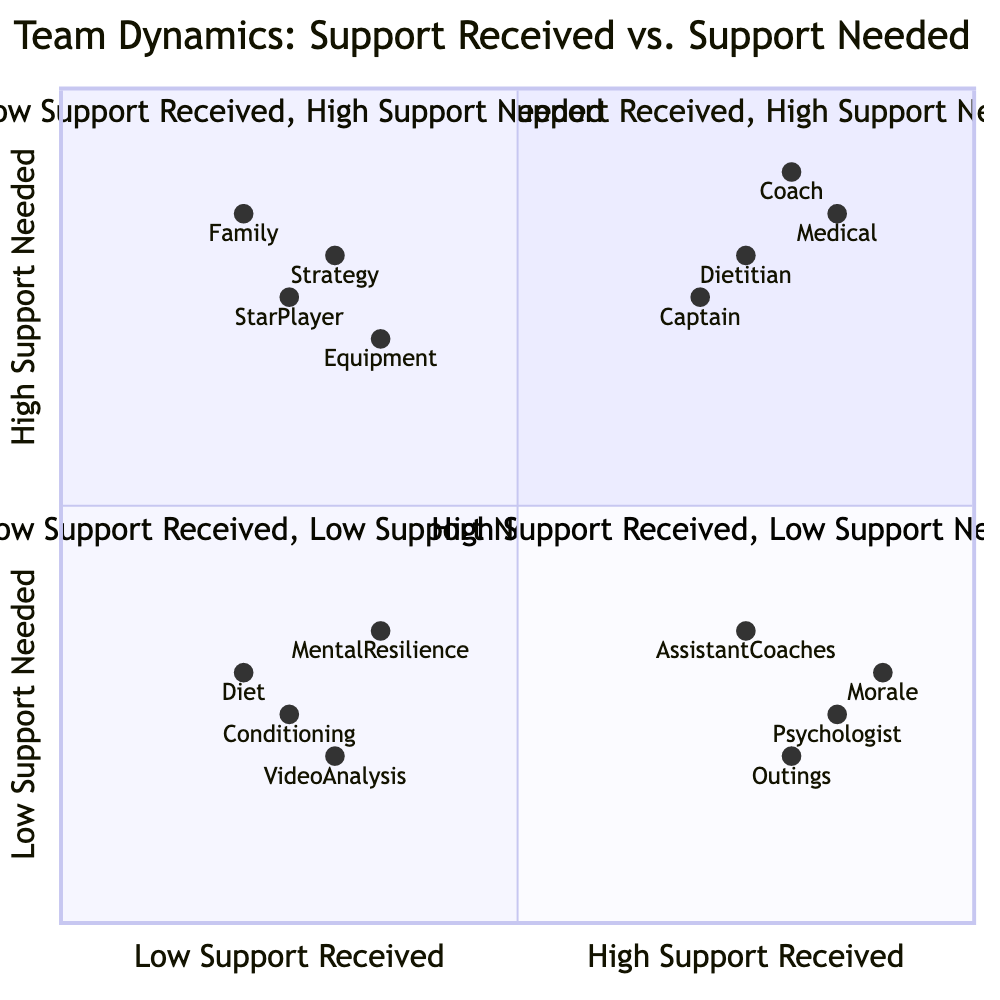What does quadrant 1 represent? Quadrant 1 is labeled "High Support Received, High Support Needed." This indicates that in this area, both the support received by individuals and the support they require is high.
Answer: High Support Received, High Support Needed Which element in quadrant 2 indicates a need for emotional support? In quadrant 2, the element "Emotional support from family" highlights a high need for support, indicating a lack of received support, as shown in this quadrant.
Answer: Emotional support from family How many elements are in quadrant 3? Quadrant 3 includes four elements listed, which are: "Daily team morale meetings," "Frequent messages from team psychologist," "Social outings organized by teammates," and "Assistance from assistant coaches." Therefore, counting these gives four elements.
Answer: 4 What is the support situation illustrated in quadrant 4? Quadrant 4 is marked "Low Support Received, Low Support Needed," illustrating a scenario where individuals do not require much support and are also not receiving much support.
Answer: Low Support Received, Low Support Needed Which element has frequent messages from a support figure? In quadrant 3, "Frequent messages from team psychologist" explicitly describes an element that represents frequent communication for support, hence it stands out in this quadrant.
Answer: Frequent messages from team psychologist What type of support is common in quadrant 1 from the team captain? The element "Regular check-ins from team captain (John)" in quadrant 1 indicates a type of support that involves ongoing communication and encouragement from a peer leader.
Answer: Regular check-ins from team captain (John) Which quadrant has the element related to game strategy feedback? "Feedback on game strategy during practices" can be found in quadrant 2, where it signifies that players perceive a high need for this feedback, yet they are receiving low support in this context.
Answer: Low Support Received, High Support Needed Which quadrant would you find social outings organized by teammates? Social outings fall under quadrant 3, which indicates that while there is high support received, the need for support is low in this scenario.
Answer: High Support Received, Low Support Needed 